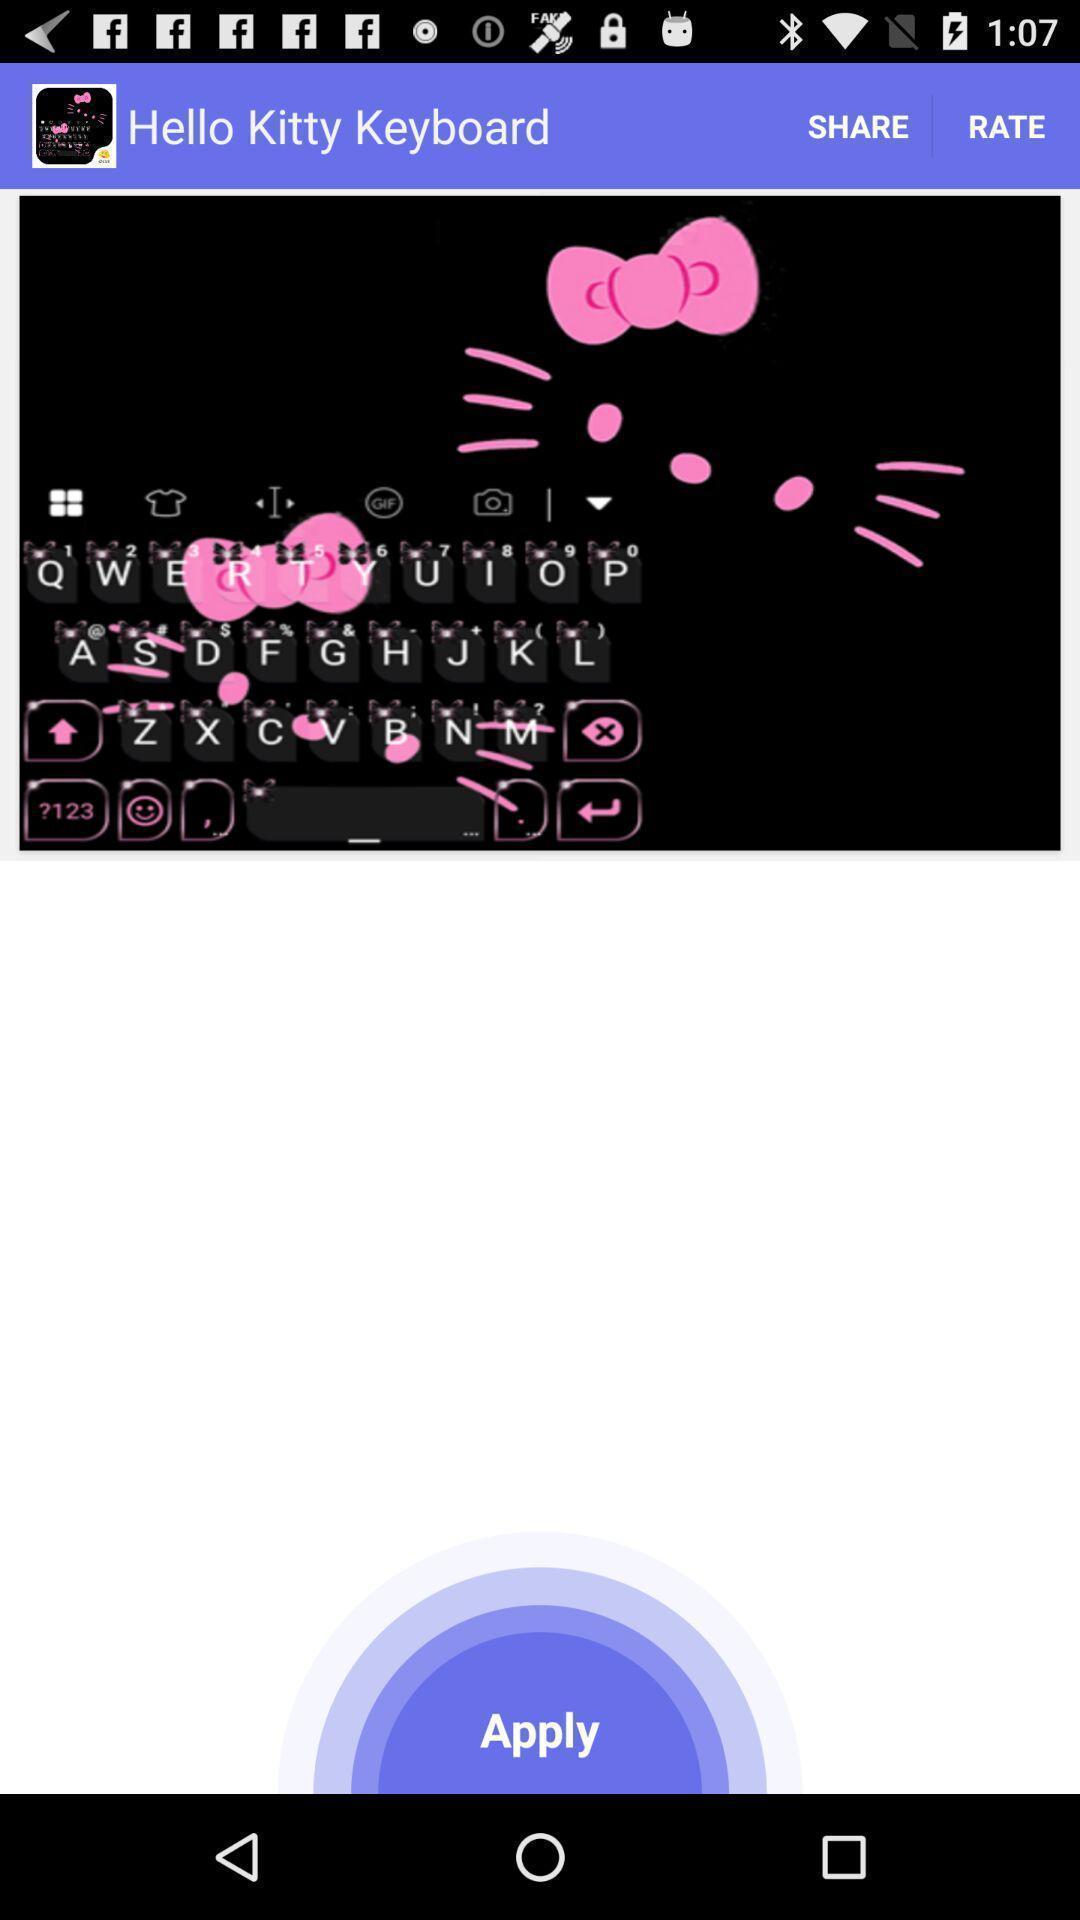Give me a summary of this screen capture. Page showing emoji keyboard. 